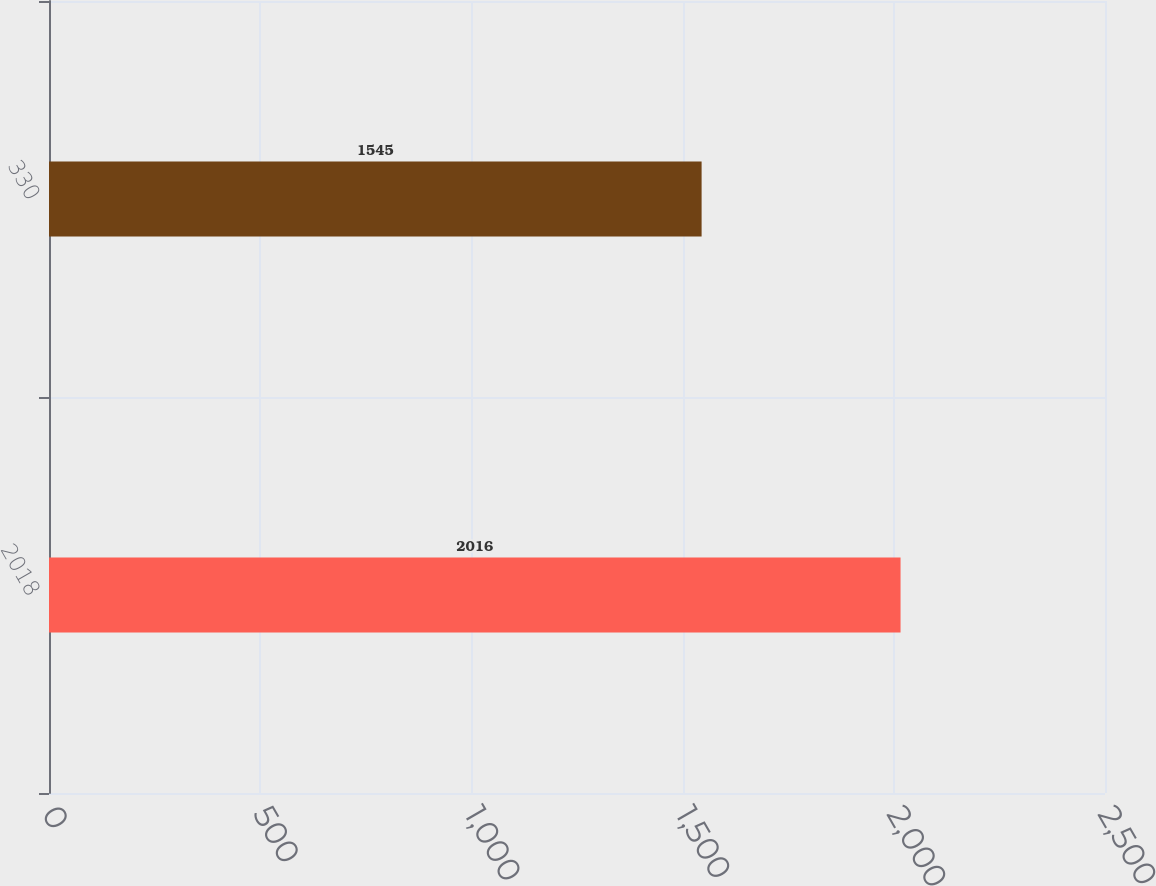Convert chart. <chart><loc_0><loc_0><loc_500><loc_500><bar_chart><fcel>2018<fcel>330<nl><fcel>2016<fcel>1545<nl></chart> 